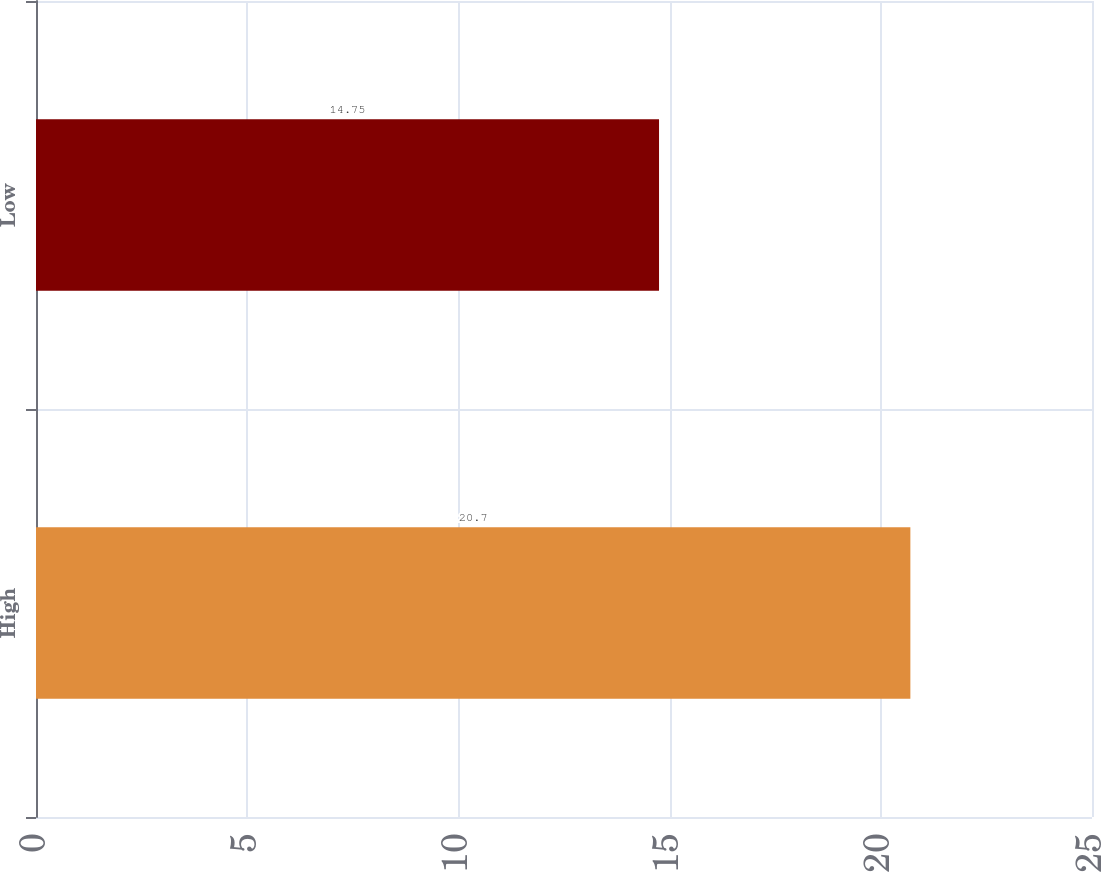Convert chart to OTSL. <chart><loc_0><loc_0><loc_500><loc_500><bar_chart><fcel>High<fcel>Low<nl><fcel>20.7<fcel>14.75<nl></chart> 